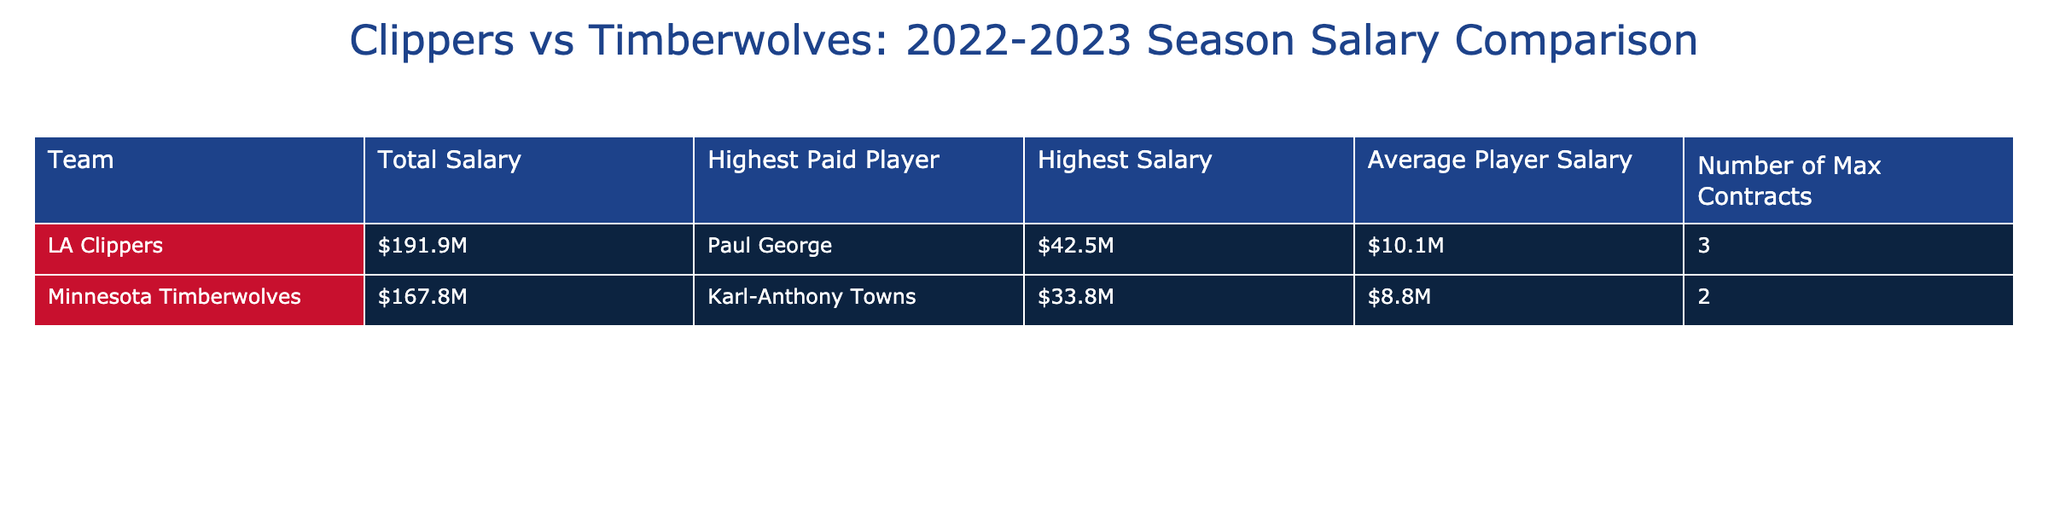What is the total salary of the LA Clippers? The total salary of the LA Clippers is explicitly listed in the table under "Total Salary." It shows $191.9M.
Answer: $191.9M Who is the highest-paid player on the Minnesota Timberwolves? The highest-paid player for the Timberwolves is stated under "Highest Paid Player" and it is Karl-Anthony Towns.
Answer: Karl-Anthony Towns How much higher is the average player salary of the Clippers compared to the Timberwolves? The average player salary for the Clippers is $10.1M and for the Timberwolves is $8.8M. The difference is $10.1M - $8.8M = $1.3M.
Answer: $1.3M Did the Timberwolves have more max contracts than the Clippers? The table shows that the Timberwolves had 2 max contracts and the Clippers had 3. Therefore, Timberwolves do not have more max contracts.
Answer: No What is the total amount of salary for both teams combined? The total salary of both teams is the sum of the two total salaries: $191.9M + $167.8M = $359.7M.
Answer: $359.7M What is the difference in total salary between the Clippers and the Timberwolves? To find the difference, subtract the Timberwolves' total salary from the Clippers' total salary: $191.9M - $167.8M = $24.1M.
Answer: $24.1M If we average the highest salaries of both teams, what would that be? The highest salary for the Clippers is $42.5M and for the Timberwolves is $33.8M. The average is ($42.5M + $33.8M) / 2 = $38.15M.
Answer: $38.15M Are the Clippers spending more than $20 million compared to the Timberwolves' total salary? The total salary difference between the Clippers and Timberwolves is $24.1M, which is indeed more than $20M.
Answer: Yes How many total max contracts do both teams have combined? The Clippers have 3 max contracts and the Timberwolves have 2. The combined total is 3 + 2 = 5 max contracts.
Answer: 5 Which team has a higher highest salary, and by how much? The Clippers have the highest salary of $42.5M and the Timberwolves have $33.8M. The difference is $42.5M - $33.8M = $8.7M.
Answer: $8.7M 